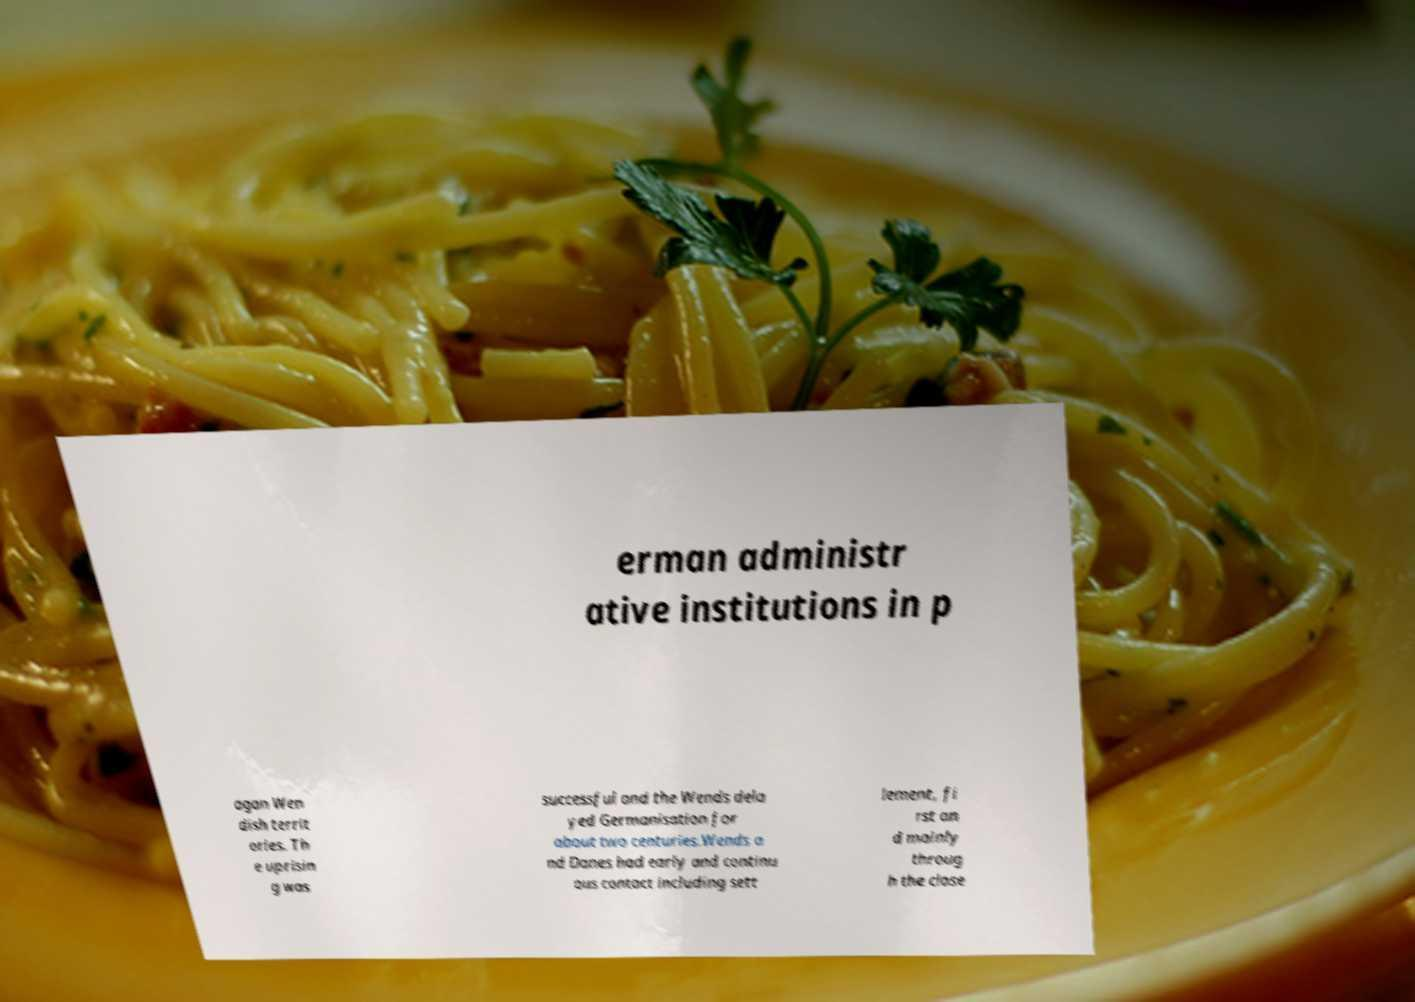Can you read and provide the text displayed in the image?This photo seems to have some interesting text. Can you extract and type it out for me? erman administr ative institutions in p agan Wen dish territ ories. Th e uprisin g was successful and the Wends dela yed Germanisation for about two centuries.Wends a nd Danes had early and continu ous contact including sett lement, fi rst an d mainly throug h the close 